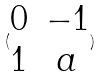Convert formula to latex. <formula><loc_0><loc_0><loc_500><loc_500>( \begin{matrix} 0 & - 1 \\ 1 & a \\ \end{matrix} )</formula> 